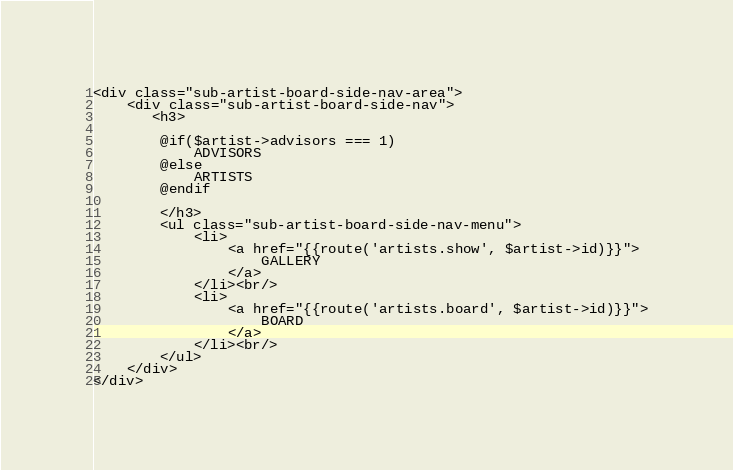Convert code to text. <code><loc_0><loc_0><loc_500><loc_500><_PHP_><div class="sub-artist-board-side-nav-area">
    <div class="sub-artist-board-side-nav">
       <h3>

        @if($artist->advisors === 1)
            ADVISORS
        @else
            ARTISTS
        @endif

        </h3>
        <ul class="sub-artist-board-side-nav-menu">
            <li>
                <a href="{{route('artists.show', $artist->id)}}">
                    GALLERY
                </a>
            </li><br/>
            <li>
                <a href="{{route('artists.board', $artist->id)}}">
                    BOARD
                </a>
            </li><br/>
        </ul>
    </div>
</div></code> 